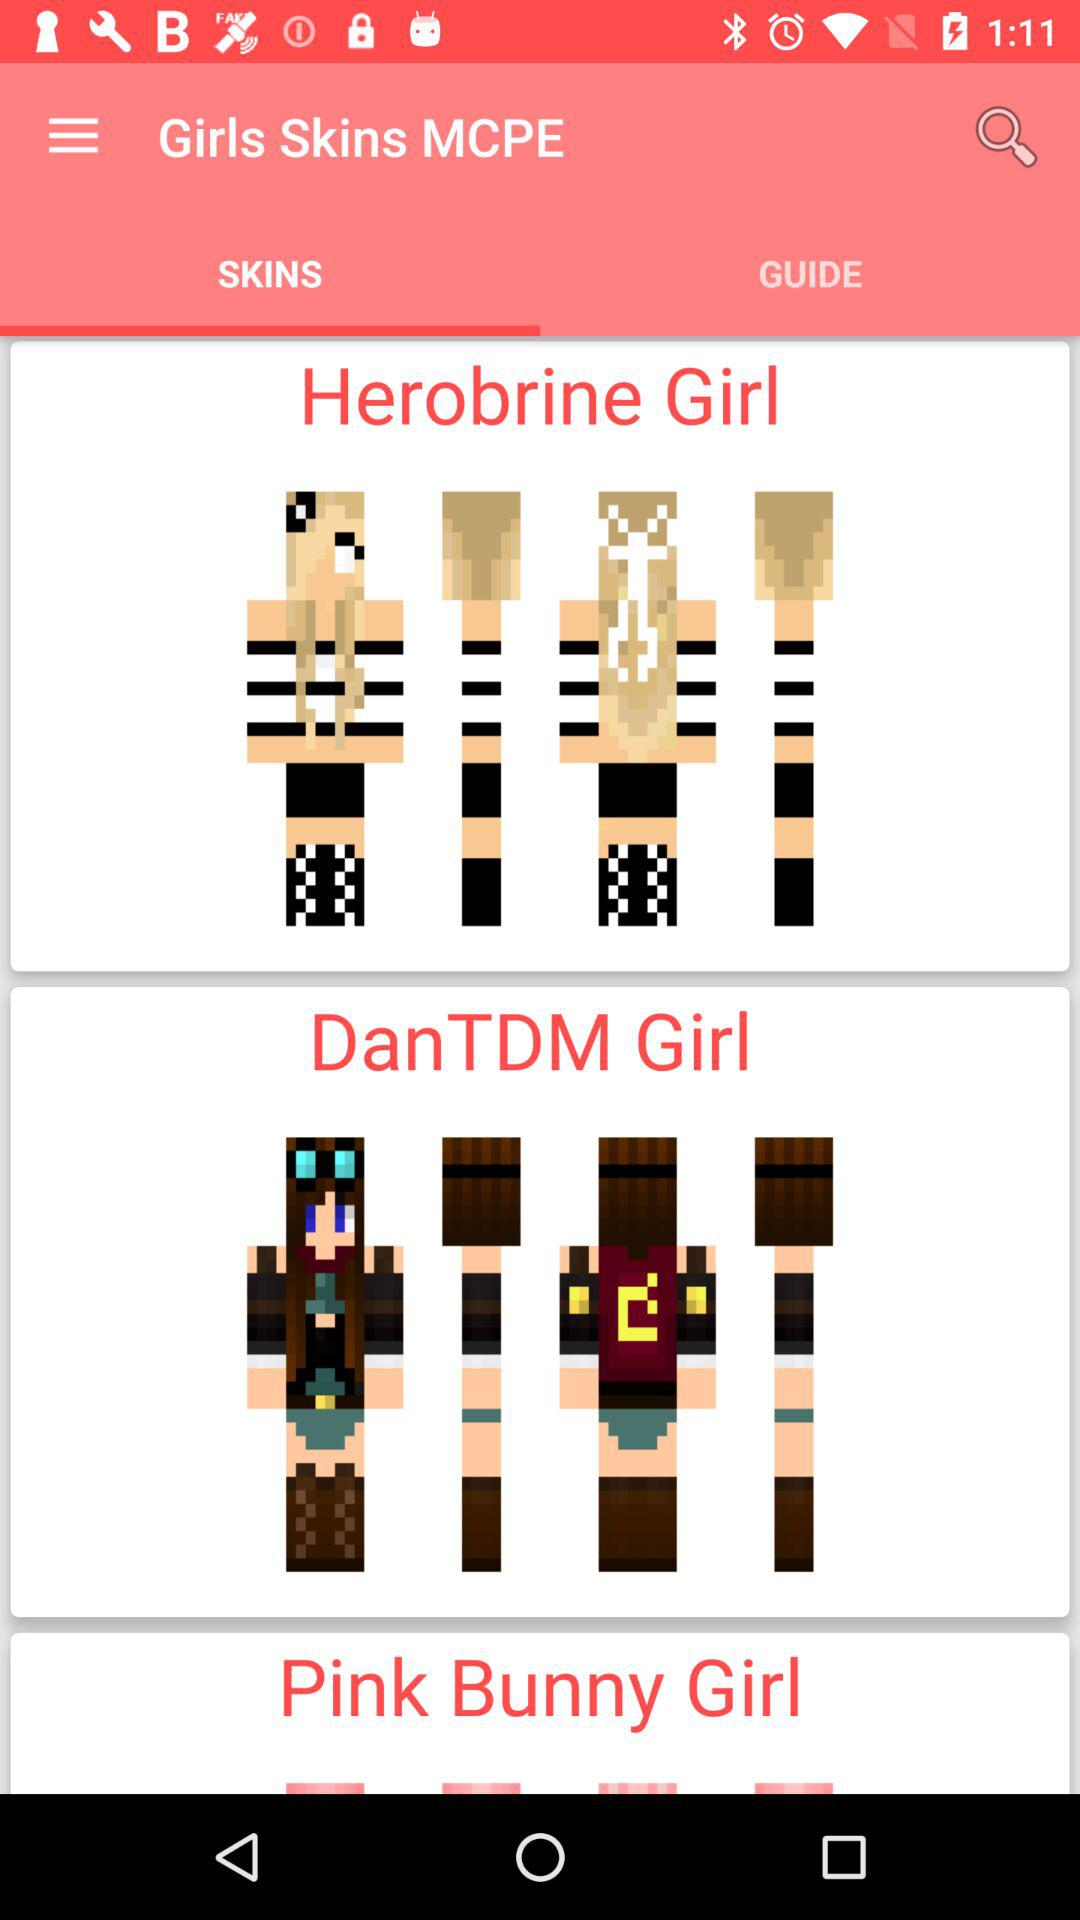Which tab is selected? The selected tab is "SKINS". 